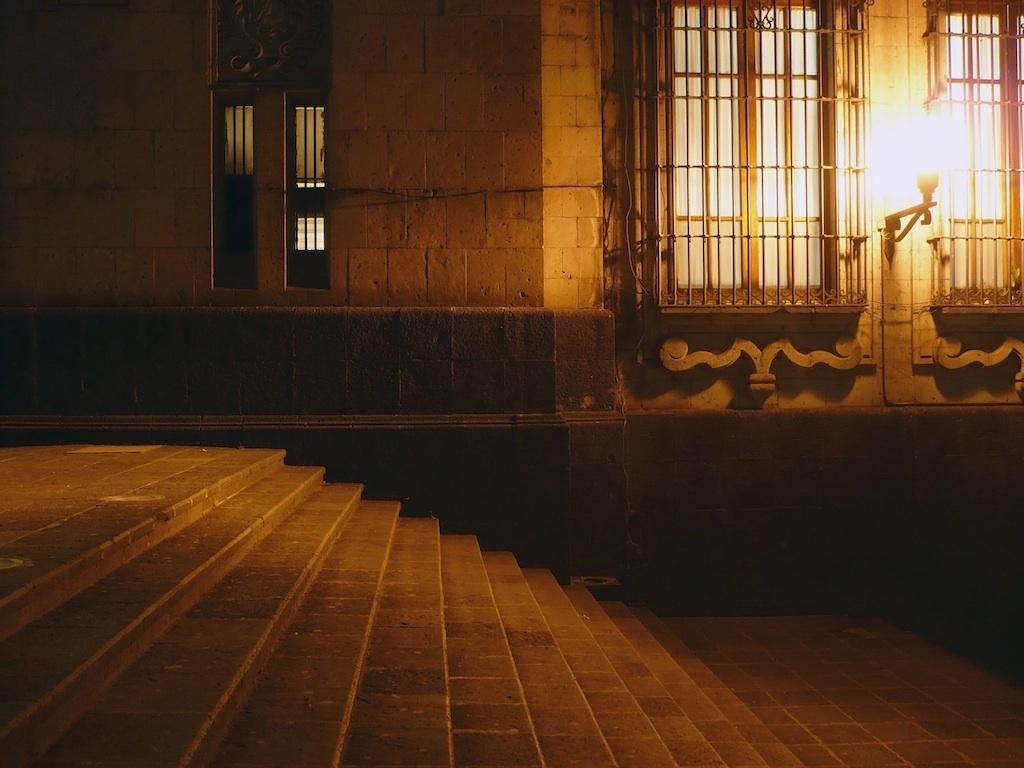Describe this image in one or two sentences. In this image at the bottom there are stairs, and in the background there are windows, light and wall. 